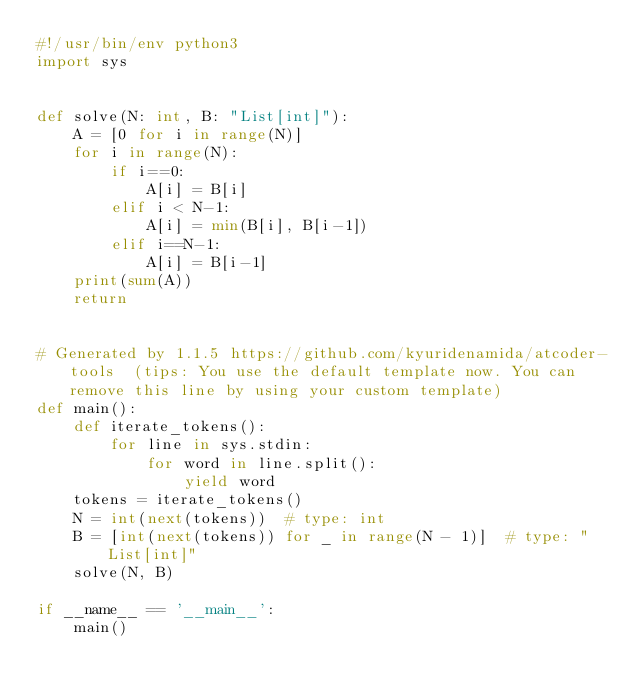<code> <loc_0><loc_0><loc_500><loc_500><_Python_>#!/usr/bin/env python3
import sys


def solve(N: int, B: "List[int]"):
    A = [0 for i in range(N)]
    for i in range(N):
        if i==0:
            A[i] = B[i]
        elif i < N-1:
            A[i] = min(B[i], B[i-1])
        elif i==N-1:
            A[i] = B[i-1]
    print(sum(A))
    return


# Generated by 1.1.5 https://github.com/kyuridenamida/atcoder-tools  (tips: You use the default template now. You can remove this line by using your custom template)
def main():
    def iterate_tokens():
        for line in sys.stdin:
            for word in line.split():
                yield word
    tokens = iterate_tokens()
    N = int(next(tokens))  # type: int
    B = [int(next(tokens)) for _ in range(N - 1)]  # type: "List[int]"
    solve(N, B)

if __name__ == '__main__':
    main()
</code> 